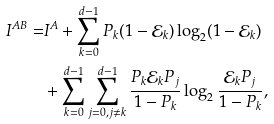Convert formula to latex. <formula><loc_0><loc_0><loc_500><loc_500>I ^ { A B } = & I ^ { A } + \sum _ { k = 0 } ^ { d - 1 } P _ { k } ( 1 - \mathcal { E } _ { k } ) \log _ { 2 } ( 1 - \mathcal { E } _ { k } ) \\ & + \sum _ { k = 0 } ^ { d - 1 } \sum _ { j = 0 , j \neq k } ^ { d - 1 } \frac { P _ { k } \mathcal { E } _ { k } P _ { j } } { 1 - P _ { k } } \log _ { 2 } \frac { \mathcal { E } _ { k } P _ { j } } { 1 - P _ { k } } ,</formula> 